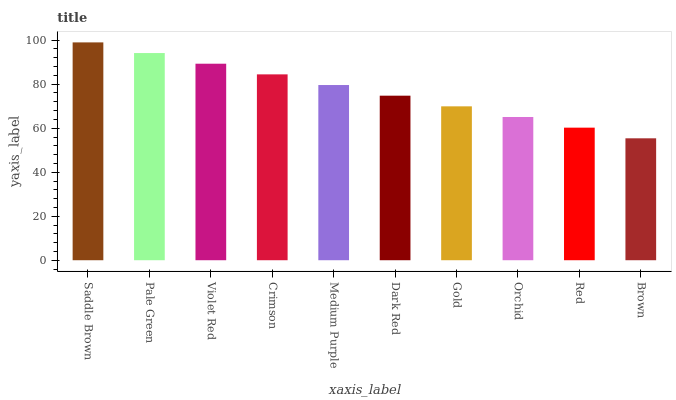Is Brown the minimum?
Answer yes or no. Yes. Is Saddle Brown the maximum?
Answer yes or no. Yes. Is Pale Green the minimum?
Answer yes or no. No. Is Pale Green the maximum?
Answer yes or no. No. Is Saddle Brown greater than Pale Green?
Answer yes or no. Yes. Is Pale Green less than Saddle Brown?
Answer yes or no. Yes. Is Pale Green greater than Saddle Brown?
Answer yes or no. No. Is Saddle Brown less than Pale Green?
Answer yes or no. No. Is Medium Purple the high median?
Answer yes or no. Yes. Is Dark Red the low median?
Answer yes or no. Yes. Is Crimson the high median?
Answer yes or no. No. Is Brown the low median?
Answer yes or no. No. 